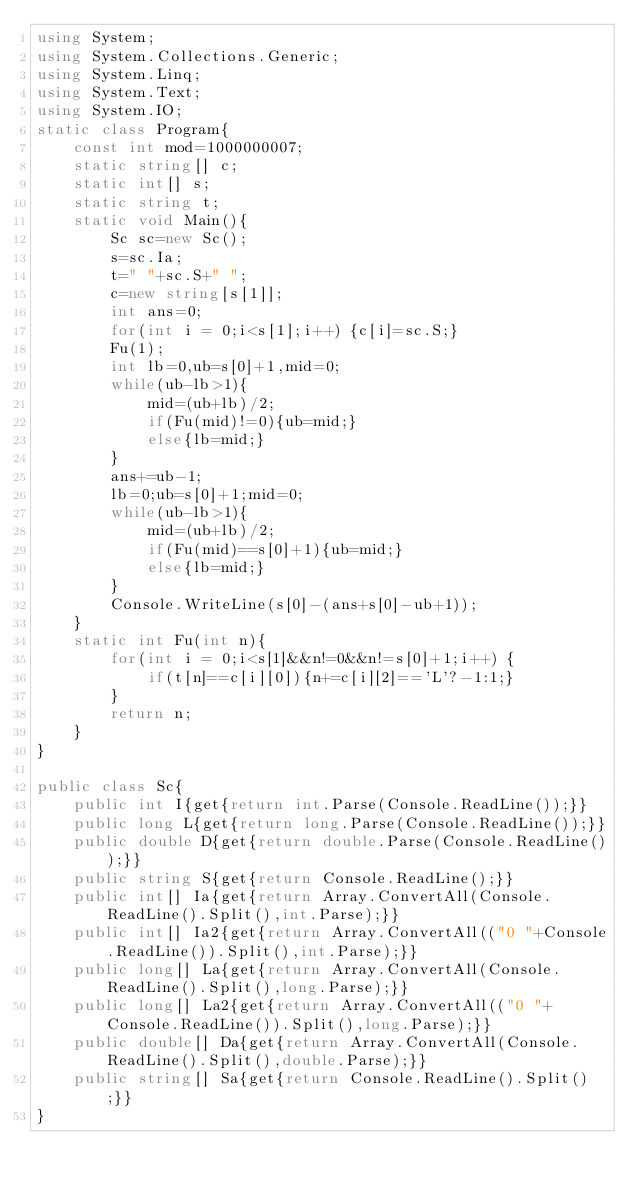Convert code to text. <code><loc_0><loc_0><loc_500><loc_500><_C#_>using System;
using System.Collections.Generic;
using System.Linq;
using System.Text;
using System.IO;
static class Program{
	const int mod=1000000007;
	static string[] c;
	static int[] s;
	static string t;
	static void Main(){
		Sc sc=new Sc();
		s=sc.Ia;
		t=" "+sc.S+" ";
		c=new string[s[1]];
		int ans=0;
		for(int i = 0;i<s[1];i++) {c[i]=sc.S;}
		Fu(1);
		int lb=0,ub=s[0]+1,mid=0;
		while(ub-lb>1){
			mid=(ub+lb)/2;
			if(Fu(mid)!=0){ub=mid;}
			else{lb=mid;}
		}
		ans+=ub-1;
		lb=0;ub=s[0]+1;mid=0;
		while(ub-lb>1){
			mid=(ub+lb)/2;
			if(Fu(mid)==s[0]+1){ub=mid;}
			else{lb=mid;}
		}
		Console.WriteLine(s[0]-(ans+s[0]-ub+1));
	}
	static int Fu(int n){
		for(int i = 0;i<s[1]&&n!=0&&n!=s[0]+1;i++) {
			if(t[n]==c[i][0]){n+=c[i][2]=='L'?-1:1;}
		}
		return n;
	}
}

public class Sc{
	public int I{get{return int.Parse(Console.ReadLine());}}
	public long L{get{return long.Parse(Console.ReadLine());}}
	public double D{get{return double.Parse(Console.ReadLine());}}
	public string S{get{return Console.ReadLine();}}
	public int[] Ia{get{return Array.ConvertAll(Console.ReadLine().Split(),int.Parse);}}
	public int[] Ia2{get{return Array.ConvertAll(("0 "+Console.ReadLine()).Split(),int.Parse);}}
	public long[] La{get{return Array.ConvertAll(Console.ReadLine().Split(),long.Parse);}}
	public long[] La2{get{return Array.ConvertAll(("0 "+Console.ReadLine()).Split(),long.Parse);}}
	public double[] Da{get{return Array.ConvertAll(Console.ReadLine().Split(),double.Parse);}}
	public string[] Sa{get{return Console.ReadLine().Split();}}
}</code> 